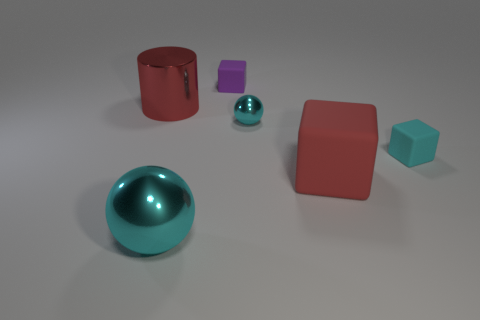There is another metal ball that is the same color as the small ball; what is its size?
Ensure brevity in your answer.  Large. There is a cyan metallic sphere that is right of the large cyan sphere; what number of tiny rubber objects are right of it?
Provide a succinct answer. 1. Is there any other thing that has the same color as the large metallic cylinder?
Provide a succinct answer. Yes. The big red object that is the same material as the cyan block is what shape?
Your answer should be very brief. Cube. Does the large shiny sphere have the same color as the small metallic thing?
Offer a terse response. Yes. Are the block that is on the left side of the big cube and the cyan block in front of the purple rubber object made of the same material?
Offer a very short reply. Yes. How many objects are either metallic things or cyan balls on the left side of the tiny metallic sphere?
Your response must be concise. 3. Is there any other thing that is the same material as the large cylinder?
Keep it short and to the point. Yes. What is the shape of the big shiny thing that is the same color as the small metallic ball?
Give a very brief answer. Sphere. What is the big cylinder made of?
Provide a succinct answer. Metal. 